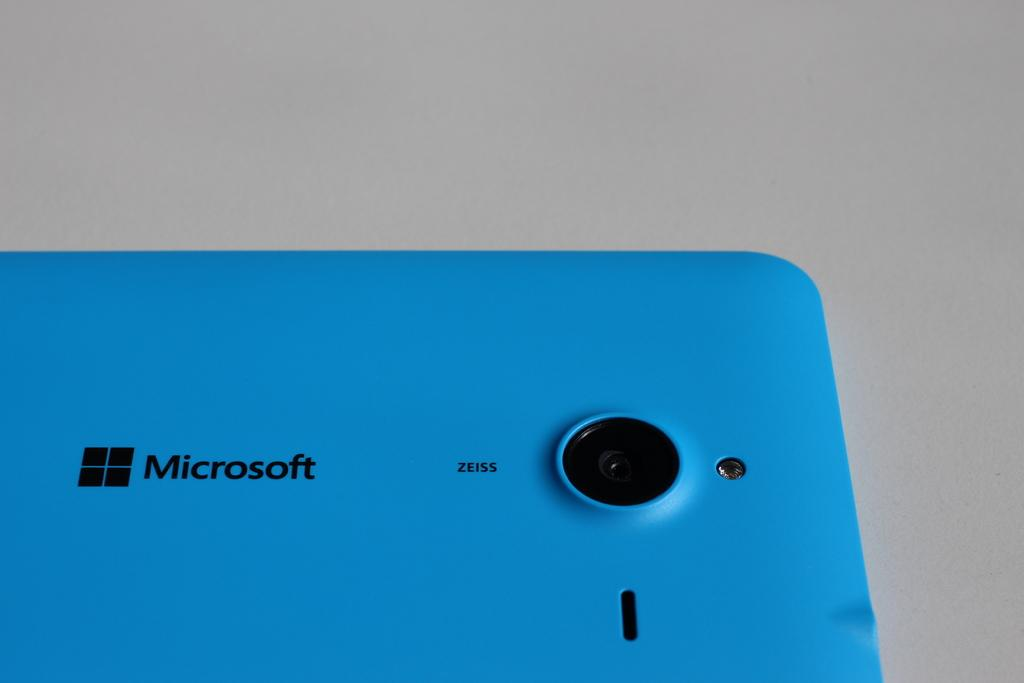Provide a one-sentence caption for the provided image. A blue Microsoft phone shows off its camera on the backside. 